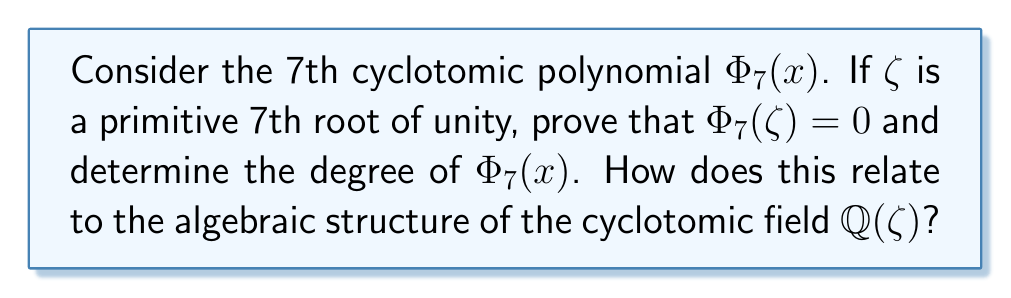Give your solution to this math problem. 1) First, recall that the 7th cyclotomic polynomial $\Phi_7(x)$ is defined as:

   $$\Phi_7(x) = \frac{x^7 - 1}{(x - 1)}$$

2) Expand this:
   
   $$\Phi_7(x) = x^6 + x^5 + x^4 + x^3 + x^2 + x + 1$$

3) Now, let $\zeta$ be a primitive 7th root of unity. This means $\zeta^7 = 1$, but $\zeta^k \neq 1$ for $1 \leq k < 7$.

4) Evaluate $\Phi_7(\zeta)$:

   $$\Phi_7(\zeta) = \zeta^6 + \zeta^5 + \zeta^4 + \zeta^3 + \zeta^2 + \zeta + 1$$

5) Since $\zeta^7 = 1$, we can multiply both sides by $(\zeta - 1)$:

   $$(\zeta - 1)\Phi_7(\zeta) = (\zeta^7 - 1) = 0$$

6) As $\zeta \neq 1$ (since it's a primitive root), we must have $\Phi_7(\zeta) = 0$.

7) The degree of $\Phi_7(x)$ is 6, which is equal to $\phi(7)$, where $\phi$ is Euler's totient function.

8) This relates to the algebraic structure of $\mathbb{Q}(\zeta)$ as follows:
   - $\mathbb{Q}(\zeta)$ is a field extension of $\mathbb{Q}$.
   - The degree of this extension is equal to the degree of $\Phi_7(x)$, which is 6.
   - This means $[\mathbb{Q}(\zeta):\mathbb{Q}] = 6$.
   - The Galois group $Gal(\mathbb{Q}(\zeta)/\mathbb{Q})$ is isomorphic to $(\mathbb{Z}/7\mathbb{Z})^*$, the multiplicative group of integers modulo 7.
Answer: $\Phi_7(\zeta) = 0$, $\deg(\Phi_7(x)) = 6$, $[\mathbb{Q}(\zeta):\mathbb{Q}] = 6$ 